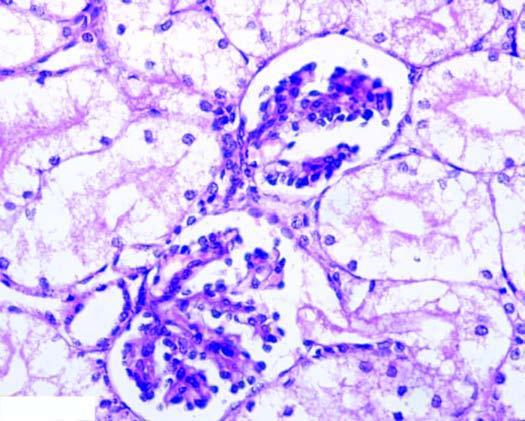s the interstitial vasculature compressed?
Answer the question using a single word or phrase. Yes 